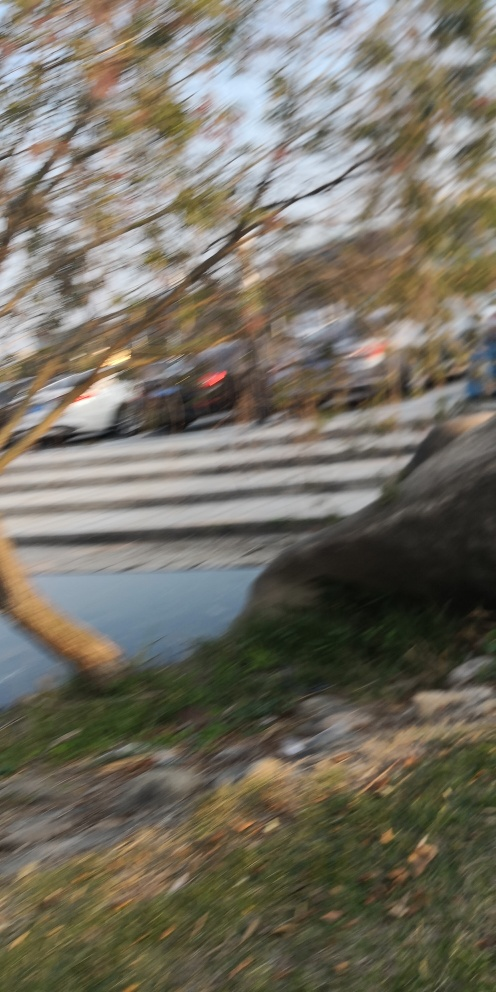What is the problem with this image?
A. The image has a problem with color saturation resulting in a muted picture.
B. The image has a problem with exposure resulting in an overexposed picture.
C. The image has a problem with focus resulting in a blurred picture.
Answer with the option's letter from the given choices directly.
 C. 